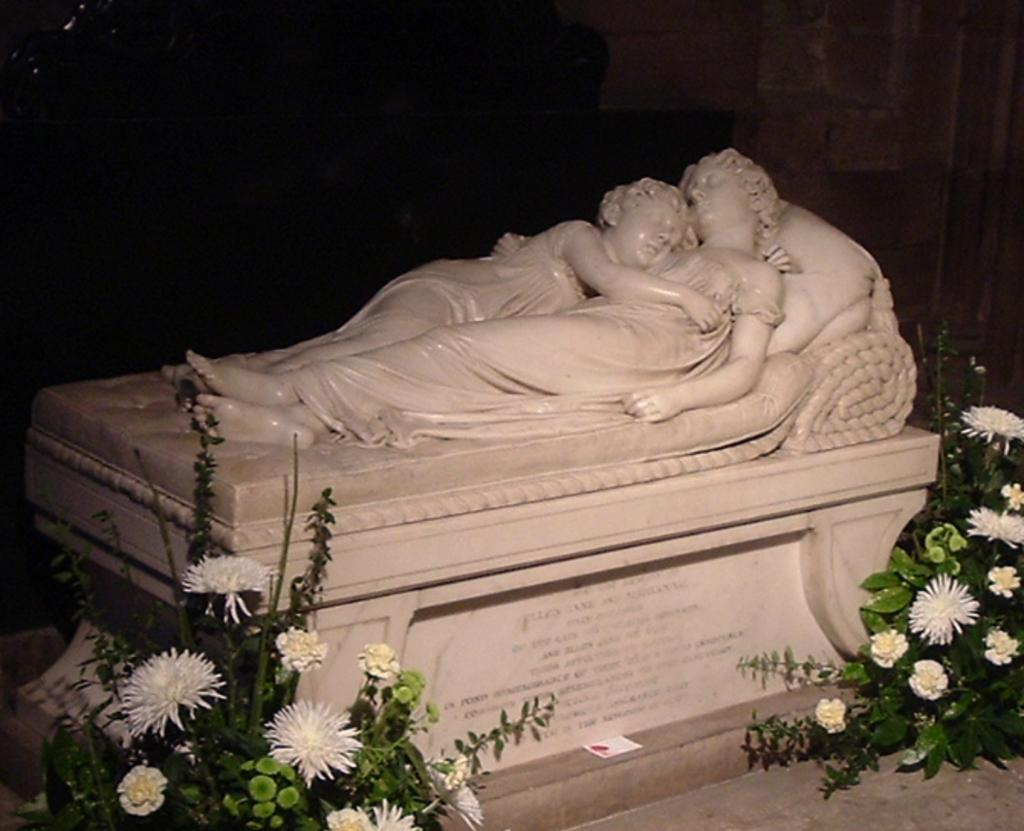What is the main subject of the image? The main subject of the image is a pedestal with statues. What are the statues depicting? The statues depict persons lying down. What type of plants can be seen in the image? There are plants with flowers and leaves in the image. How would you describe the background of the image? The background of the image is dark. How many giants are present in the image? There are no giants present in the image. What type of sorting technique is being used by the plants in the image? The plants in the image are not performing any sorting technique; they are simply growing with flowers and leaves. 